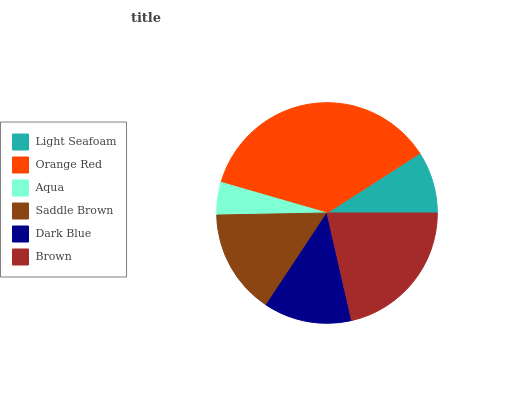Is Aqua the minimum?
Answer yes or no. Yes. Is Orange Red the maximum?
Answer yes or no. Yes. Is Orange Red the minimum?
Answer yes or no. No. Is Aqua the maximum?
Answer yes or no. No. Is Orange Red greater than Aqua?
Answer yes or no. Yes. Is Aqua less than Orange Red?
Answer yes or no. Yes. Is Aqua greater than Orange Red?
Answer yes or no. No. Is Orange Red less than Aqua?
Answer yes or no. No. Is Saddle Brown the high median?
Answer yes or no. Yes. Is Dark Blue the low median?
Answer yes or no. Yes. Is Brown the high median?
Answer yes or no. No. Is Brown the low median?
Answer yes or no. No. 